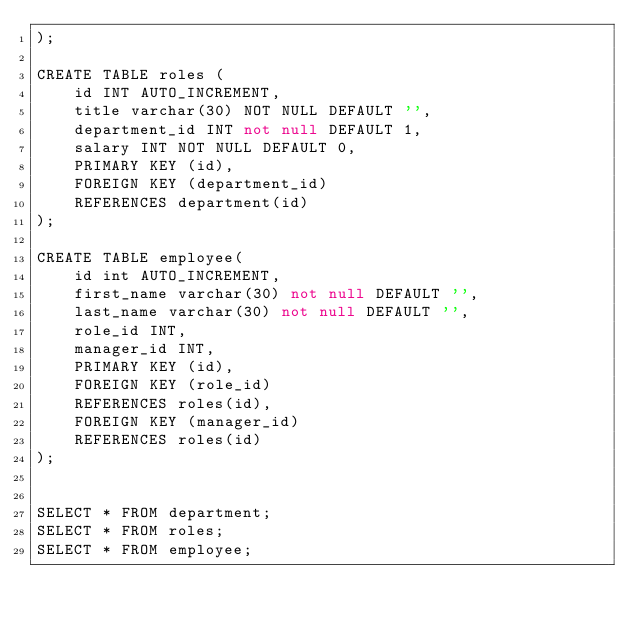Convert code to text. <code><loc_0><loc_0><loc_500><loc_500><_SQL_>);

CREATE TABLE roles (
    id INT AUTO_INCREMENT,
    title varchar(30) NOT NULL DEFAULT '',
    department_id INT not null DEFAULT 1,
    salary INT NOT NULL DEFAULT 0,
    PRIMARY KEY (id),
    FOREIGN KEY (department_id)
    REFERENCES department(id)
);

CREATE TABLE employee(
    id int AUTO_INCREMENT,
    first_name varchar(30) not null DEFAULT '',
    last_name varchar(30) not null DEFAULT '', 
    role_id INT,
    manager_id INT,
    PRIMARY KEY (id),
    FOREIGN KEY (role_id)
    REFERENCES roles(id),
    FOREIGN KEY (manager_id)
    REFERENCES roles(id)
);


SELECT * FROM department;
SELECT * FROM roles;
SELECT * FROM employee;</code> 